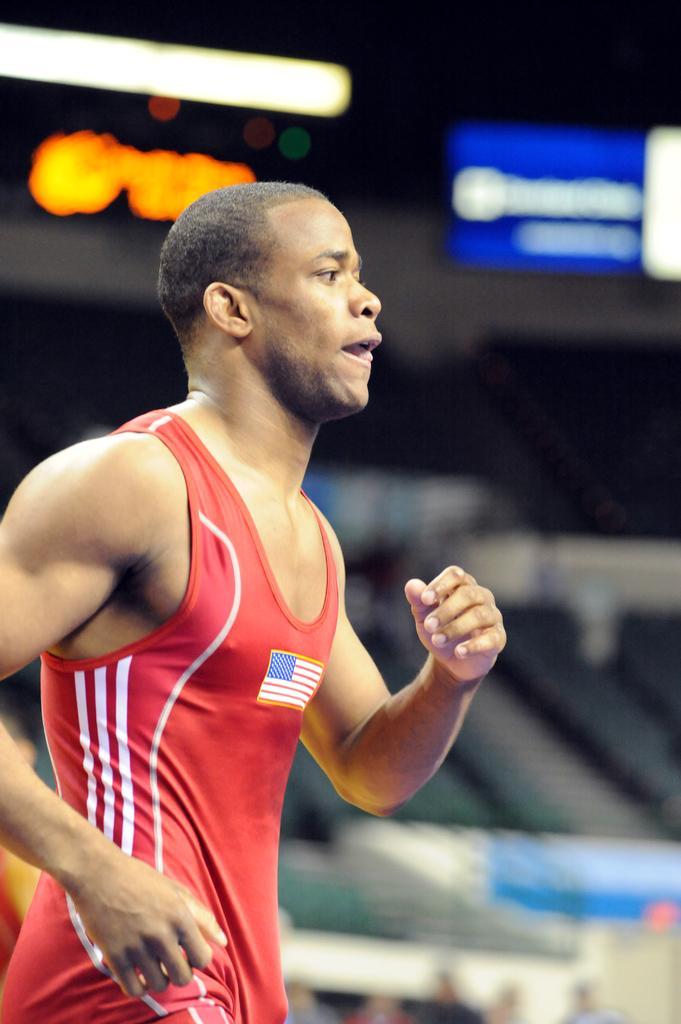Could you give a brief overview of what you see in this image? On the left side, there is a person in red color t-shirt, running. And the background is blurred. 